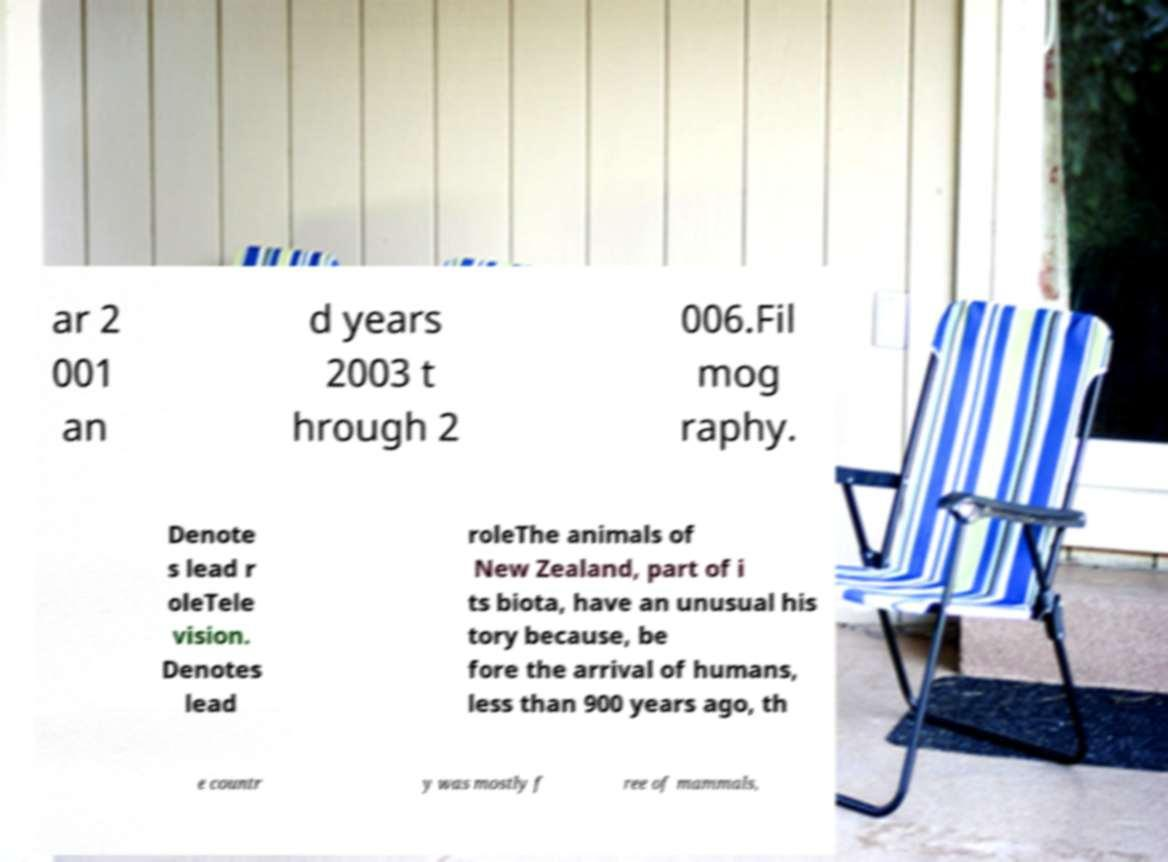For documentation purposes, I need the text within this image transcribed. Could you provide that? ar 2 001 an d years 2003 t hrough 2 006.Fil mog raphy. Denote s lead r oleTele vision. Denotes lead roleThe animals of New Zealand, part of i ts biota, have an unusual his tory because, be fore the arrival of humans, less than 900 years ago, th e countr y was mostly f ree of mammals, 